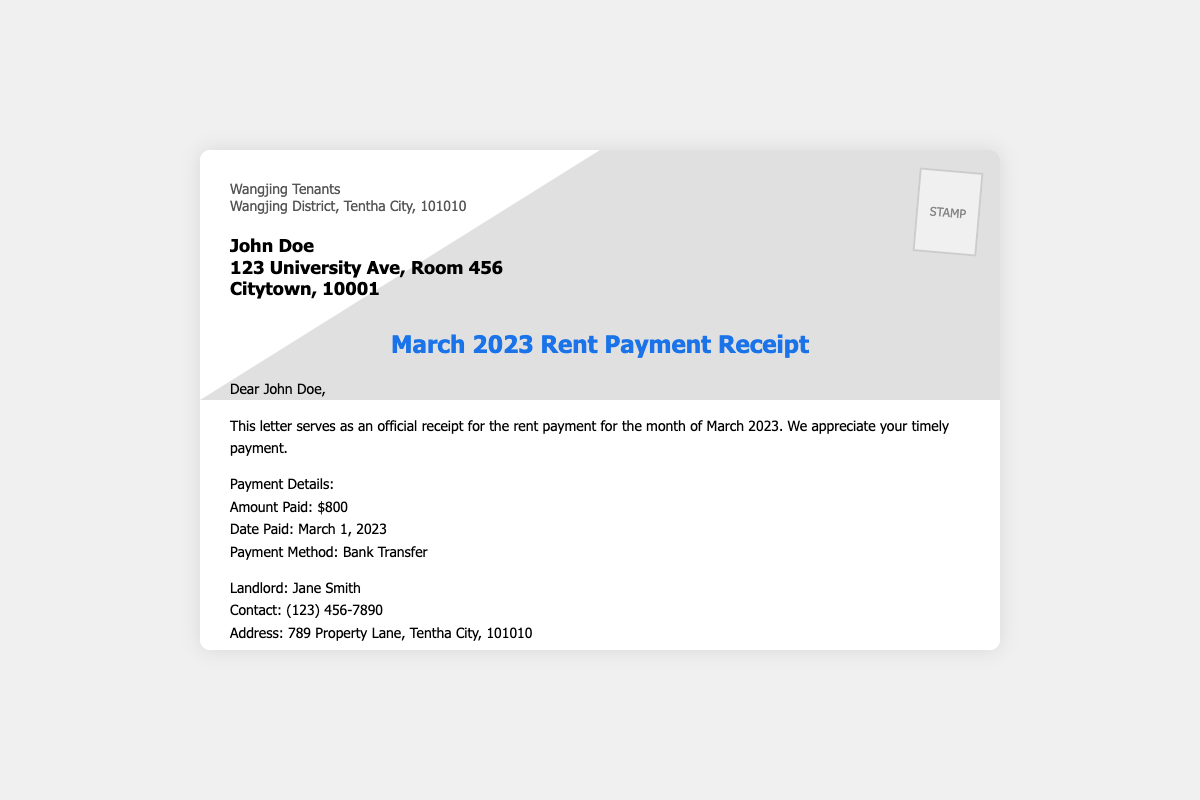What is the amount paid for rent? The amount paid for rent is stated in the payment details section of the document, which specifies the payment amount.
Answer: $800 What is the date the rent was paid? The date of payment is provided in the payment details section, indicating when the transaction took place.
Answer: March 1, 2023 Who is the landlord? The landlord's name is identified in the contact section of the document, specifying who is receiving the rent payment.
Answer: Jane Smith What is the property address? The property address is provided within the document, detailing where the rented property is located.
Answer: Apartment 789, No. 56 Wangjing Street, Tentha City, 101010 What payment method was used? The method of payment is described in the payment details, outlining how the payment was completed.
Answer: Bank Transfer What is the contact number of the landlord? The landlord's contact number is listed in the document for any inquiries regarding the rental agreement.
Answer: (123) 456-7890 What city is the sender located in? The sender's address includes specifications about their location, which includes the city name.
Answer: Tentha City How was the payment described in the letter? The letter mentions how the payment is perceived concerning timeliness and appreciation.
Answer: Timely payment What is stated at the end of the document? The end of the document includes a polite closing message from the organization sending the receipt.
Answer: Best regards, Wangjing Tenants 